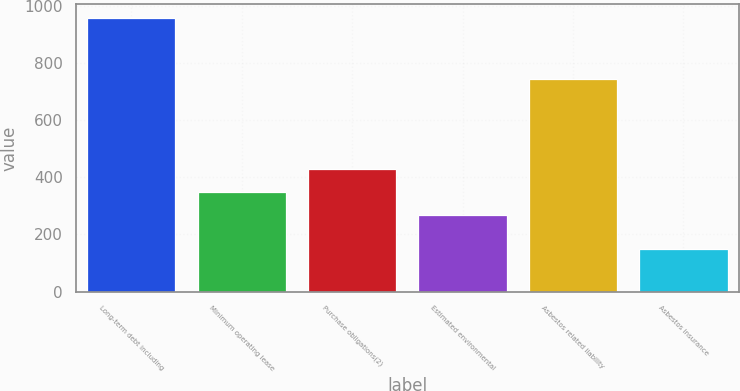Convert chart. <chart><loc_0><loc_0><loc_500><loc_500><bar_chart><fcel>Long-term debt including<fcel>Minimum operating lease<fcel>Purchase obligations(2)<fcel>Estimated environmental<fcel>Asbestos related liability<fcel>Asbestos insurance<nl><fcel>956<fcel>347.6<fcel>428.2<fcel>267<fcel>744<fcel>150<nl></chart> 